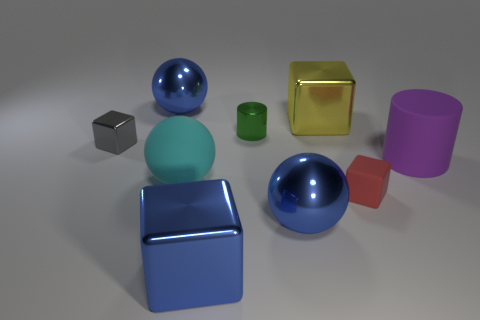Are the big sphere that is behind the big yellow shiny block and the thing to the right of the small red block made of the same material?
Offer a terse response. No. Are there any big blue metallic balls in front of the tiny matte thing?
Your answer should be compact. Yes. How many blue things are metallic blocks or blocks?
Offer a terse response. 1. Do the small green object and the cylinder to the right of the red matte object have the same material?
Provide a succinct answer. No. There is a blue metal object that is the same shape as the small red object; what size is it?
Make the answer very short. Large. What is the cyan thing made of?
Offer a terse response. Rubber. What material is the big blue thing that is behind the shiny thing that is right of the big shiny sphere that is in front of the small red rubber block made of?
Provide a succinct answer. Metal. Is the size of the cube that is right of the large yellow thing the same as the cylinder that is behind the matte cylinder?
Your answer should be compact. Yes. What number of other things are there of the same material as the purple thing
Offer a terse response. 2. How many rubber objects are either big brown cylinders or blue balls?
Your answer should be compact. 0. 